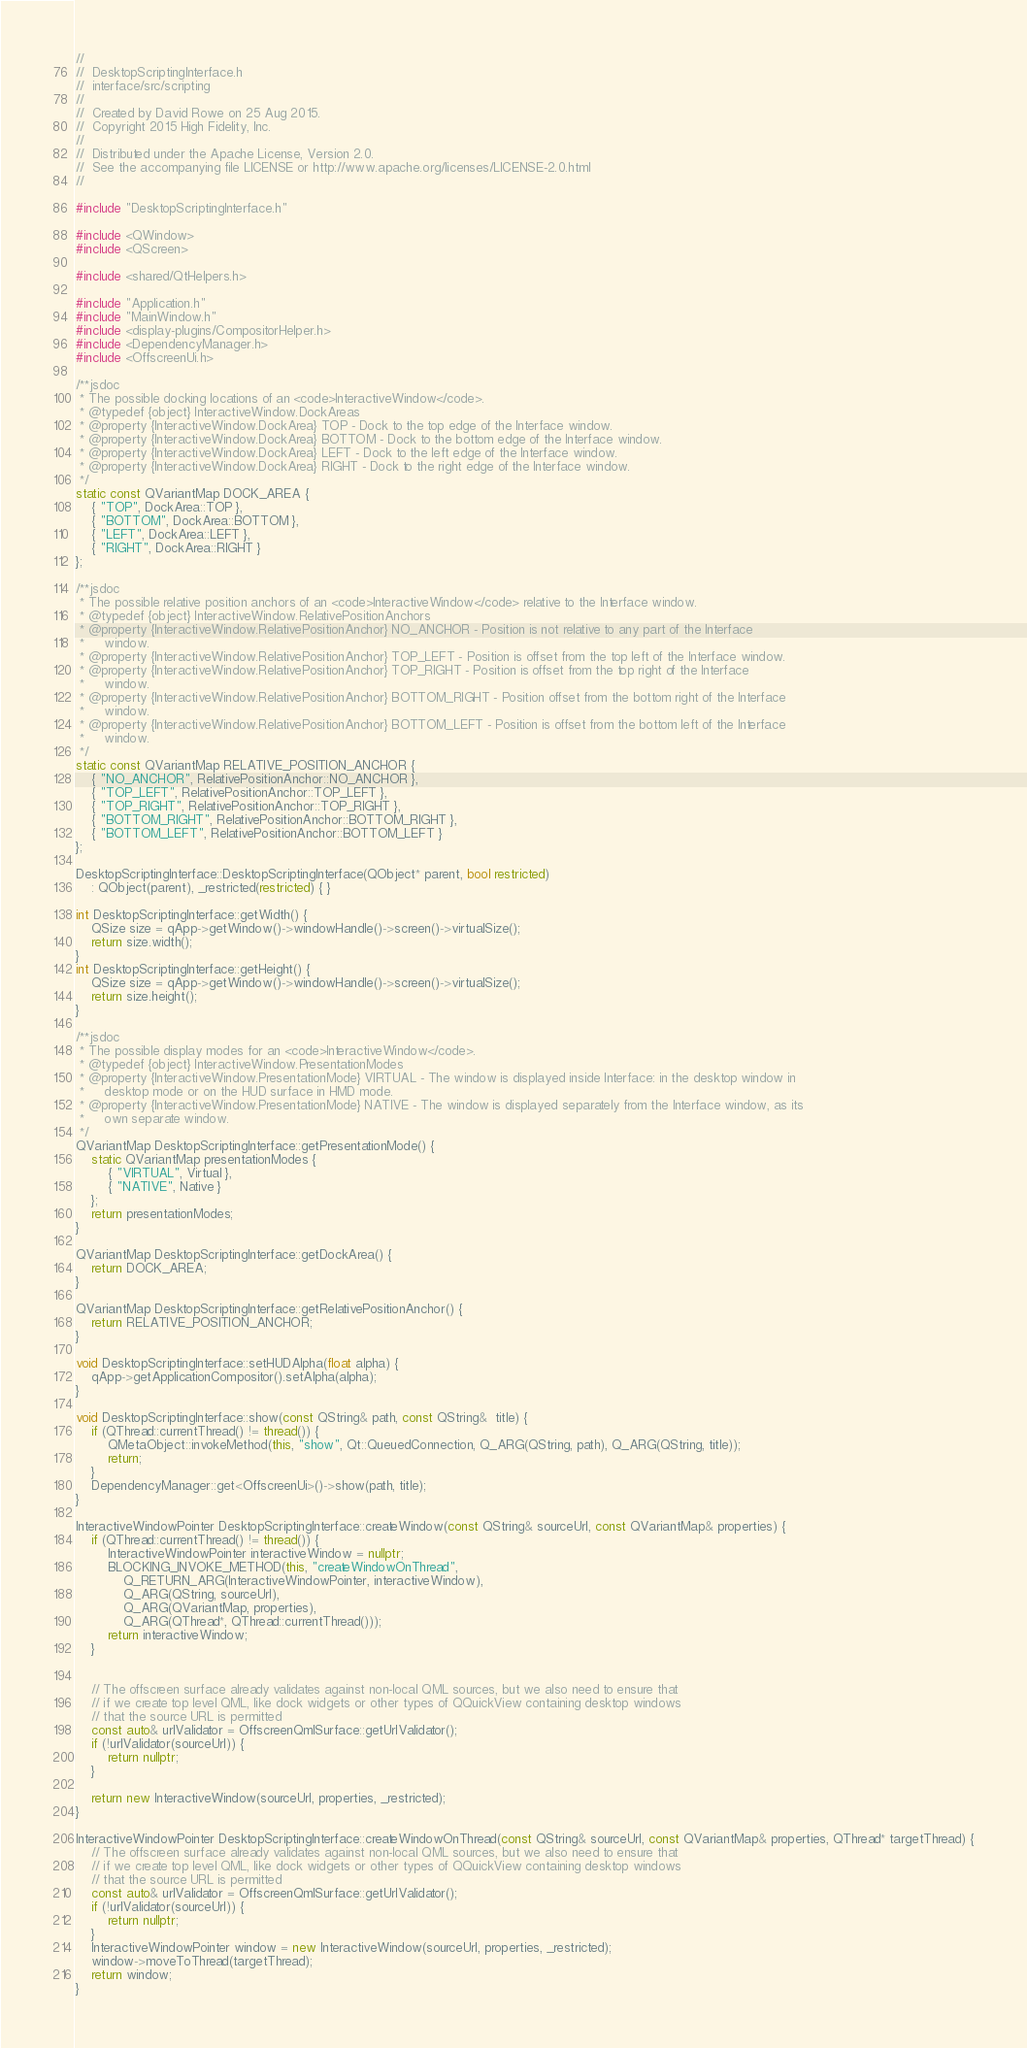<code> <loc_0><loc_0><loc_500><loc_500><_C++_>//
//  DesktopScriptingInterface.h
//  interface/src/scripting
//
//  Created by David Rowe on 25 Aug 2015.
//  Copyright 2015 High Fidelity, Inc.
//
//  Distributed under the Apache License, Version 2.0.
//  See the accompanying file LICENSE or http://www.apache.org/licenses/LICENSE-2.0.html
//

#include "DesktopScriptingInterface.h"

#include <QWindow>
#include <QScreen>

#include <shared/QtHelpers.h>

#include "Application.h"
#include "MainWindow.h"
#include <display-plugins/CompositorHelper.h>
#include <DependencyManager.h>
#include <OffscreenUi.h>

/**jsdoc
 * The possible docking locations of an <code>InteractiveWindow</code>.
 * @typedef {object} InteractiveWindow.DockAreas
 * @property {InteractiveWindow.DockArea} TOP - Dock to the top edge of the Interface window.
 * @property {InteractiveWindow.DockArea} BOTTOM - Dock to the bottom edge of the Interface window.
 * @property {InteractiveWindow.DockArea} LEFT - Dock to the left edge of the Interface window.
 * @property {InteractiveWindow.DockArea} RIGHT - Dock to the right edge of the Interface window.
 */
static const QVariantMap DOCK_AREA {
    { "TOP", DockArea::TOP },
    { "BOTTOM", DockArea::BOTTOM },
    { "LEFT", DockArea::LEFT },
    { "RIGHT", DockArea::RIGHT }
};

/**jsdoc
 * The possible relative position anchors of an <code>InteractiveWindow</code> relative to the Interface window.
 * @typedef {object} InteractiveWindow.RelativePositionAnchors
 * @property {InteractiveWindow.RelativePositionAnchor} NO_ANCHOR - Position is not relative to any part of the Interface 
 *     window.
 * @property {InteractiveWindow.RelativePositionAnchor} TOP_LEFT - Position is offset from the top left of the Interface window.
 * @property {InteractiveWindow.RelativePositionAnchor} TOP_RIGHT - Position is offset from the top right of the Interface 
 *     window.
 * @property {InteractiveWindow.RelativePositionAnchor} BOTTOM_RIGHT - Position offset from the bottom right of the Interface 
 *     window.
 * @property {InteractiveWindow.RelativePositionAnchor} BOTTOM_LEFT - Position is offset from the bottom left of the Interface 
 *     window.
 */
static const QVariantMap RELATIVE_POSITION_ANCHOR {
    { "NO_ANCHOR", RelativePositionAnchor::NO_ANCHOR },
    { "TOP_LEFT", RelativePositionAnchor::TOP_LEFT },
    { "TOP_RIGHT", RelativePositionAnchor::TOP_RIGHT },
    { "BOTTOM_RIGHT", RelativePositionAnchor::BOTTOM_RIGHT },
    { "BOTTOM_LEFT", RelativePositionAnchor::BOTTOM_LEFT }
};

DesktopScriptingInterface::DesktopScriptingInterface(QObject* parent, bool restricted) 
    : QObject(parent), _restricted(restricted) { }

int DesktopScriptingInterface::getWidth() {
    QSize size = qApp->getWindow()->windowHandle()->screen()->virtualSize();
    return size.width();
}
int DesktopScriptingInterface::getHeight() {
    QSize size = qApp->getWindow()->windowHandle()->screen()->virtualSize();
    return size.height();
}

/**jsdoc
 * The possible display modes for an <code>InteractiveWindow</code>.
 * @typedef {object} InteractiveWindow.PresentationModes
 * @property {InteractiveWindow.PresentationMode} VIRTUAL - The window is displayed inside Interface: in the desktop window in 
 *     desktop mode or on the HUD surface in HMD mode.
 * @property {InteractiveWindow.PresentationMode} NATIVE - The window is displayed separately from the Interface window, as its 
 *     own separate window.
 */
QVariantMap DesktopScriptingInterface::getPresentationMode() {
    static QVariantMap presentationModes {
        { "VIRTUAL", Virtual },
        { "NATIVE", Native }
    };
    return presentationModes;
}

QVariantMap DesktopScriptingInterface::getDockArea() {
    return DOCK_AREA;
}

QVariantMap DesktopScriptingInterface::getRelativePositionAnchor() {
    return RELATIVE_POSITION_ANCHOR;
}

void DesktopScriptingInterface::setHUDAlpha(float alpha) {
    qApp->getApplicationCompositor().setAlpha(alpha);
}

void DesktopScriptingInterface::show(const QString& path, const QString&  title) {
    if (QThread::currentThread() != thread()) {
        QMetaObject::invokeMethod(this, "show", Qt::QueuedConnection, Q_ARG(QString, path), Q_ARG(QString, title));
        return;
    }
    DependencyManager::get<OffscreenUi>()->show(path, title);
}

InteractiveWindowPointer DesktopScriptingInterface::createWindow(const QString& sourceUrl, const QVariantMap& properties) {
    if (QThread::currentThread() != thread()) {
        InteractiveWindowPointer interactiveWindow = nullptr;
        BLOCKING_INVOKE_METHOD(this, "createWindowOnThread",
            Q_RETURN_ARG(InteractiveWindowPointer, interactiveWindow),
            Q_ARG(QString, sourceUrl),
            Q_ARG(QVariantMap, properties),
            Q_ARG(QThread*, QThread::currentThread()));
        return interactiveWindow;
    }


    // The offscreen surface already validates against non-local QML sources, but we also need to ensure that 
    // if we create top level QML, like dock widgets or other types of QQuickView containing desktop windows 
    // that the source URL is permitted
    const auto& urlValidator = OffscreenQmlSurface::getUrlValidator();
    if (!urlValidator(sourceUrl)) {
        return nullptr;
    }

    return new InteractiveWindow(sourceUrl, properties, _restricted);
}

InteractiveWindowPointer DesktopScriptingInterface::createWindowOnThread(const QString& sourceUrl, const QVariantMap& properties, QThread* targetThread) {
    // The offscreen surface already validates against non-local QML sources, but we also need to ensure that 
    // if we create top level QML, like dock widgets or other types of QQuickView containing desktop windows 
    // that the source URL is permitted
    const auto& urlValidator = OffscreenQmlSurface::getUrlValidator();
    if (!urlValidator(sourceUrl)) {
        return nullptr;
    }
    InteractiveWindowPointer window = new InteractiveWindow(sourceUrl, properties, _restricted);
    window->moveToThread(targetThread);
    return window;
}
</code> 